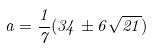<formula> <loc_0><loc_0><loc_500><loc_500>a = \frac { 1 } { 7 } ( 3 4 \pm 6 \sqrt { 2 1 } )</formula> 